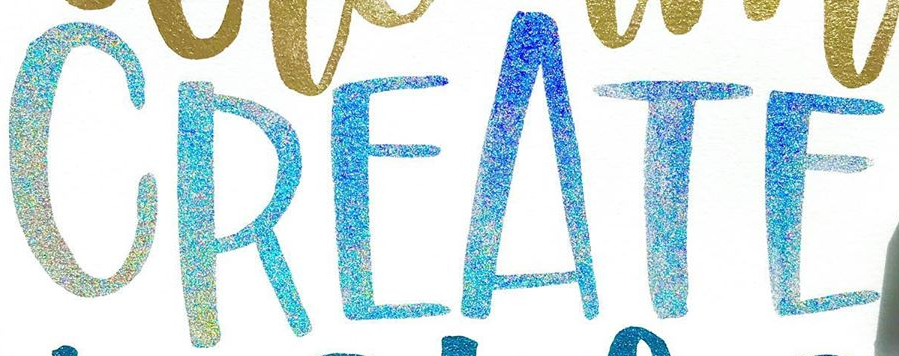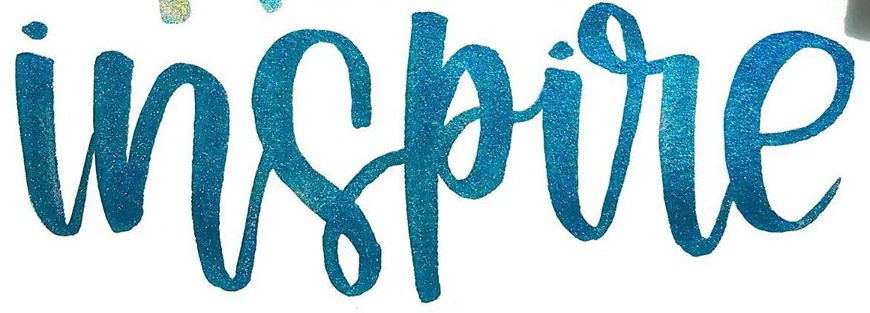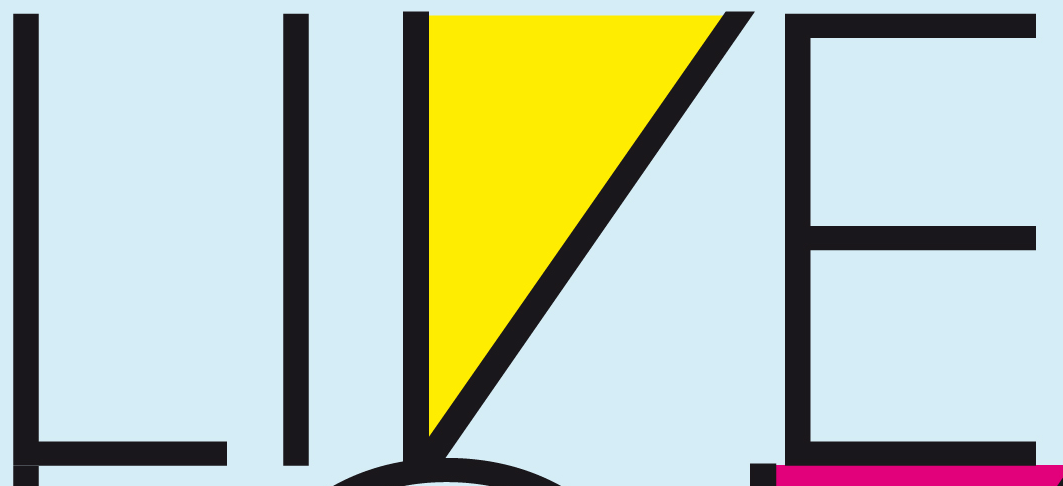Read the text content from these images in order, separated by a semicolon. CREATE; inspire; LIVE 